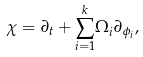<formula> <loc_0><loc_0><loc_500><loc_500>\chi = \partial _ { t } + { { { \sum _ { i = 1 } ^ { k } } } } \Omega _ { i } \partial _ { \phi _ { i } } ,</formula> 